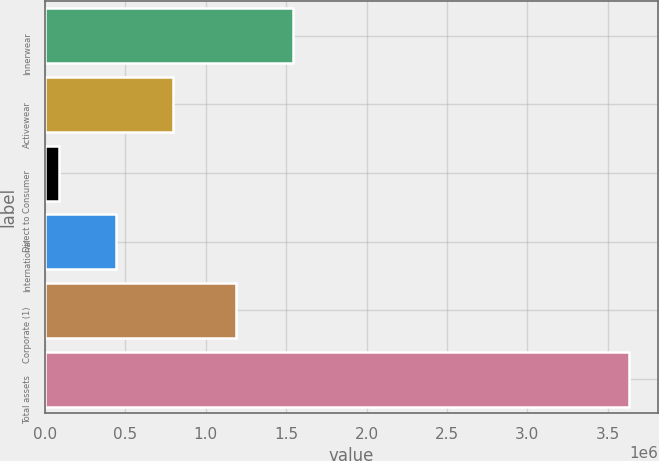Convert chart to OTSL. <chart><loc_0><loc_0><loc_500><loc_500><bar_chart><fcel>Innerwear<fcel>Activewear<fcel>Direct to Consumer<fcel>International<fcel>Corporate (1)<fcel>Total assets<nl><fcel>1.5419e+06<fcel>795256<fcel>86145<fcel>440700<fcel>1.18735e+06<fcel>3.6317e+06<nl></chart> 